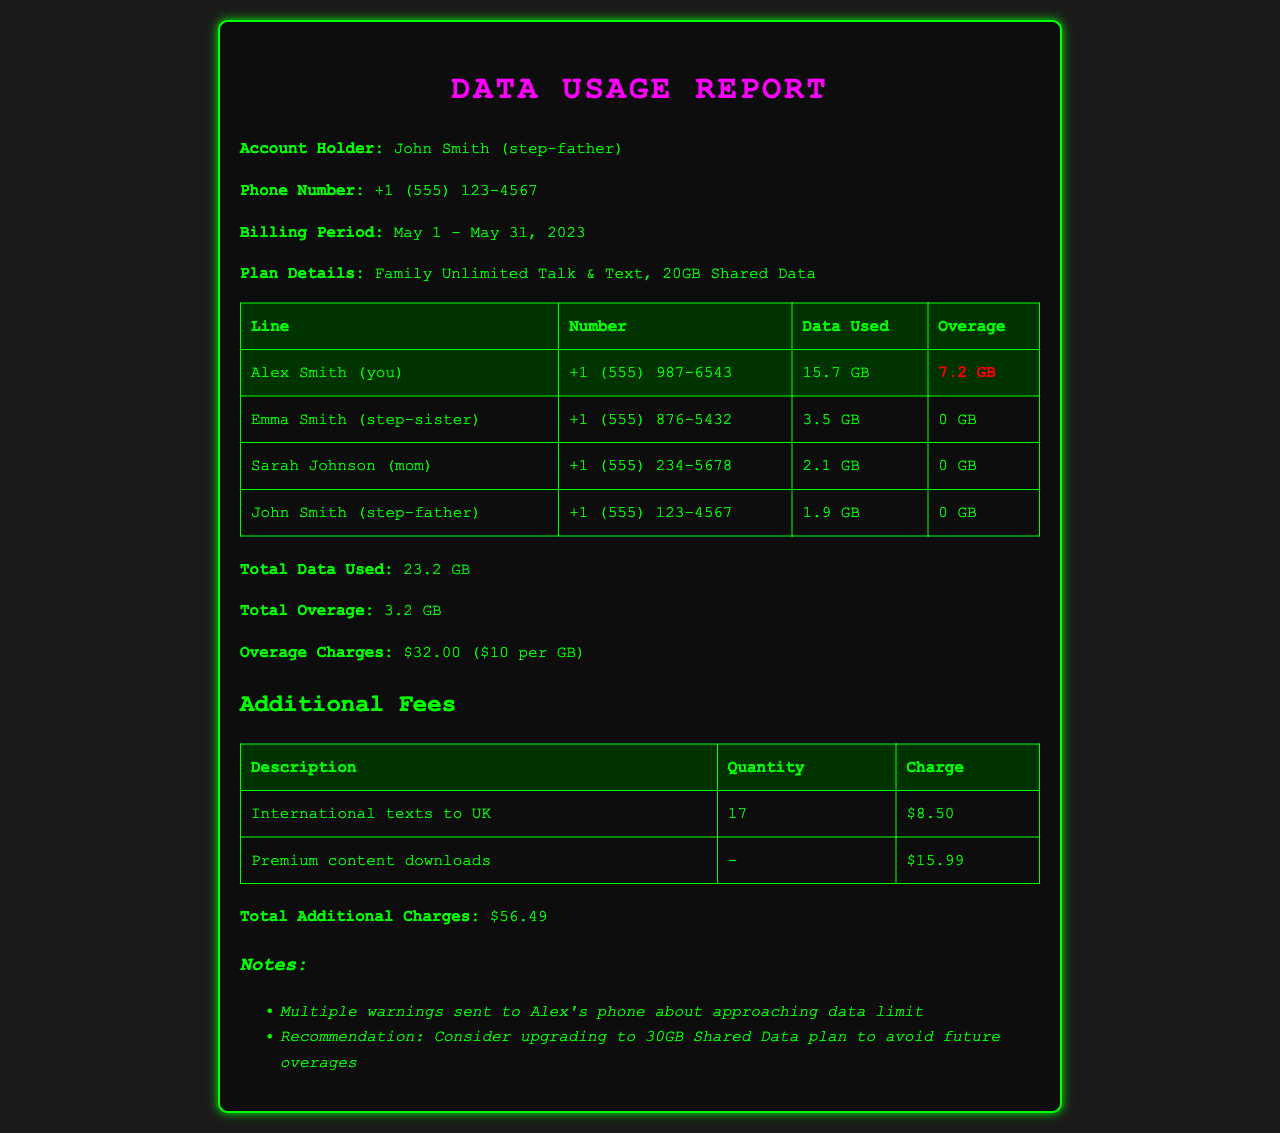What is the account holder's name? The account holder's name is mentioned in the document, which is John Smith.
Answer: John Smith What is the total data used during the billing period? The total data used is provided in the summary, which is a combination of data from all lines.
Answer: 23.2 GB How much overage did Alex use? The document specifies the overage for Alex, which is listed clearly as 7.2 GB.
Answer: 7.2 GB What is the total amount charged for overage? The total overage charges are calculated based on the excess data used, which is $10 per GB for 3.2 GB.
Answer: $32.00 Which phone number has the highest data usage? The data used by each line is compared, and Alex Smith's line shows the highest usage at 15.7 GB.
Answer: +1 (555) 987-6543 What additional fees were charged for international texts? The document lists the charge for international texts to the UK specifically as $8.50.
Answer: $8.50 What is the recommendation for Alex regarding data usage? The notes section contains a recommendation suggesting an upgrade due to overages.
Answer: Upgrade to 30GB Shared Data plan How many premium content downloads were charged? The document indicates there were charges for premium content downloads but does not specify a quantity.
Answer: - What was the billing period for this report? The billing period is specified in the document as from May 1 to May 31, 2023.
Answer: May 1 - May 31, 2023 Who had no data overage during the billing period? The document provides data usage and indicates Emma and Sarah had no overage.
Answer: Emma Smith, Sarah Johnson 